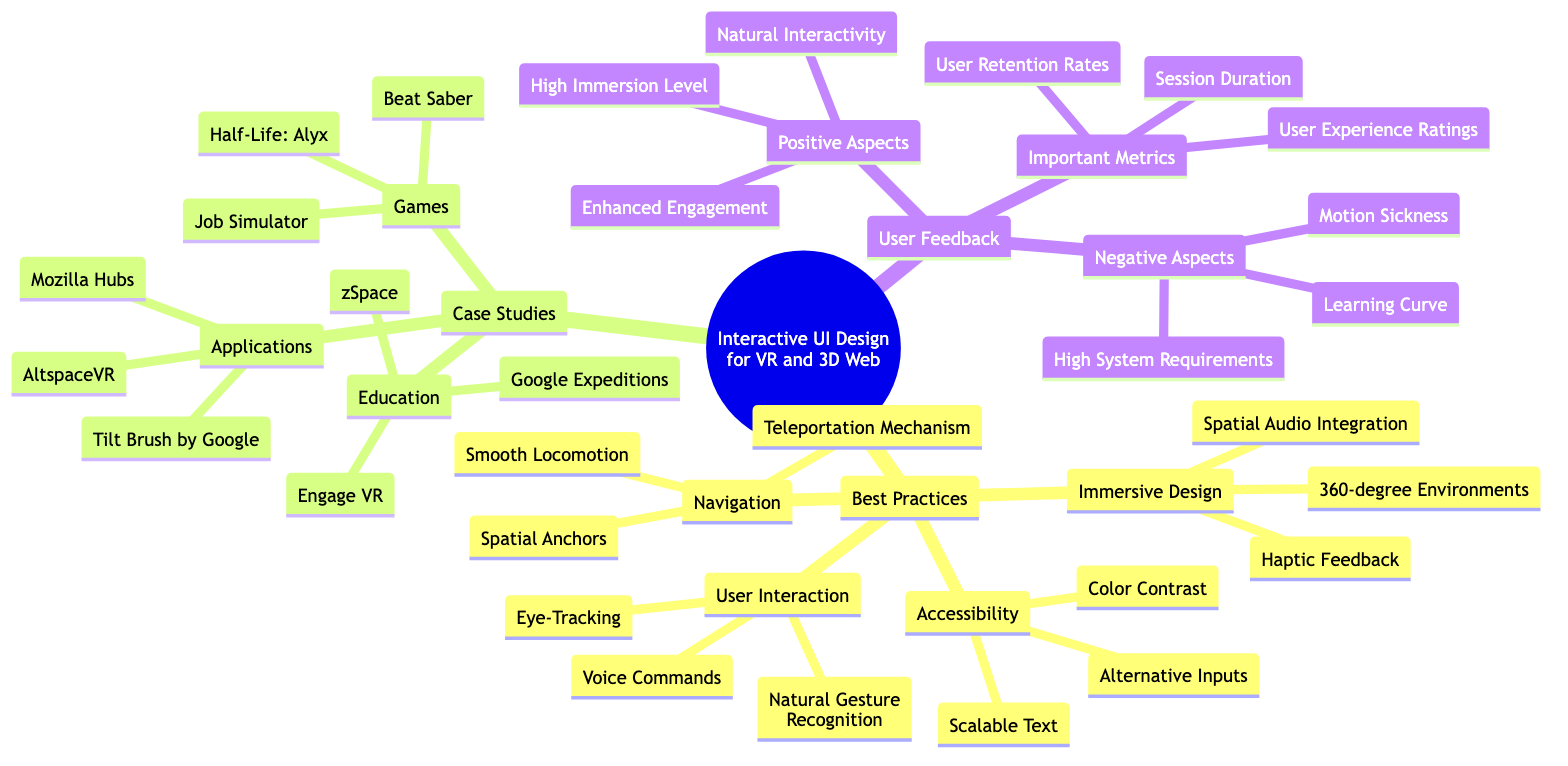What are the four categories of Best Practices in the diagram? The diagram displays the "Best Practices" node, which branches into four distinct categories: "Immersive Design," "User Interaction," "Navigation," and "Accessibility."
Answer: Immersive Design, User Interaction, Navigation, Accessibility Which game is listed under Case Studies? The "Case Studies" section includes a subcategory labeled "Games," which lists several examples. One of the games specified is "Beat Saber."
Answer: Beat Saber How many entries are under Positive Aspects in User Feedback? Within the "User Feedback" section, there is a category labeled "Positive Aspects," which comprises three specific entries: "Enhanced Engagement," "Natural Interactivity," and "High Immersion Level."
Answer: 3 What mechanism is listed under Navigation? The "Navigation" category includes multiple methods for user movement, and one of these specified is the "Teleportation Mechanism."
Answer: Teleportation Mechanism What is one negative aspect mentioned in User Feedback? The "User Feedback" section includes a category titled "Negative Aspects" where multiple challenges are outlined, such as "Motion Sickness."
Answer: Motion Sickness How are the best practices categorized? The node for "Best Practices" is divided into four specific categories: "Immersive Design," "User Interaction," "Navigation," and "Accessibility," indicating a structured approach to designing interactive user experiences.
Answer: Four categories Which application is cited under Case Studies? The "Case Studies" section features a subcategory labeled "Applications," which lists entries including "Tilt Brush by Google."
Answer: Tilt Brush by Google What is the relationship between User Feedback and Important Metrics? "User Feedback" contains a subcategory labeled "Important Metrics," which lists significant measures of user experience, demonstrating that metrics are used to evaluate user feedback effectively.
Answer: Important Metrics are evaluated post user feedback Name a user interaction method that employs gestures. The "User Interaction" category includes a method called "Natural Gesture Recognition," which employs user gestures for interaction within the interface.
Answer: Natural Gesture Recognition 